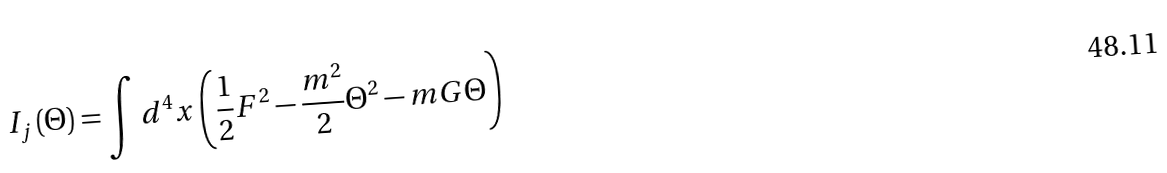Convert formula to latex. <formula><loc_0><loc_0><loc_500><loc_500>I _ { j } \left ( \Theta \right ) = \int d ^ { 4 } x \left ( \frac { 1 } { 2 } F ^ { 2 } - \frac { m ^ { 2 } } 2 \Theta ^ { 2 } - m G \Theta \right )</formula> 